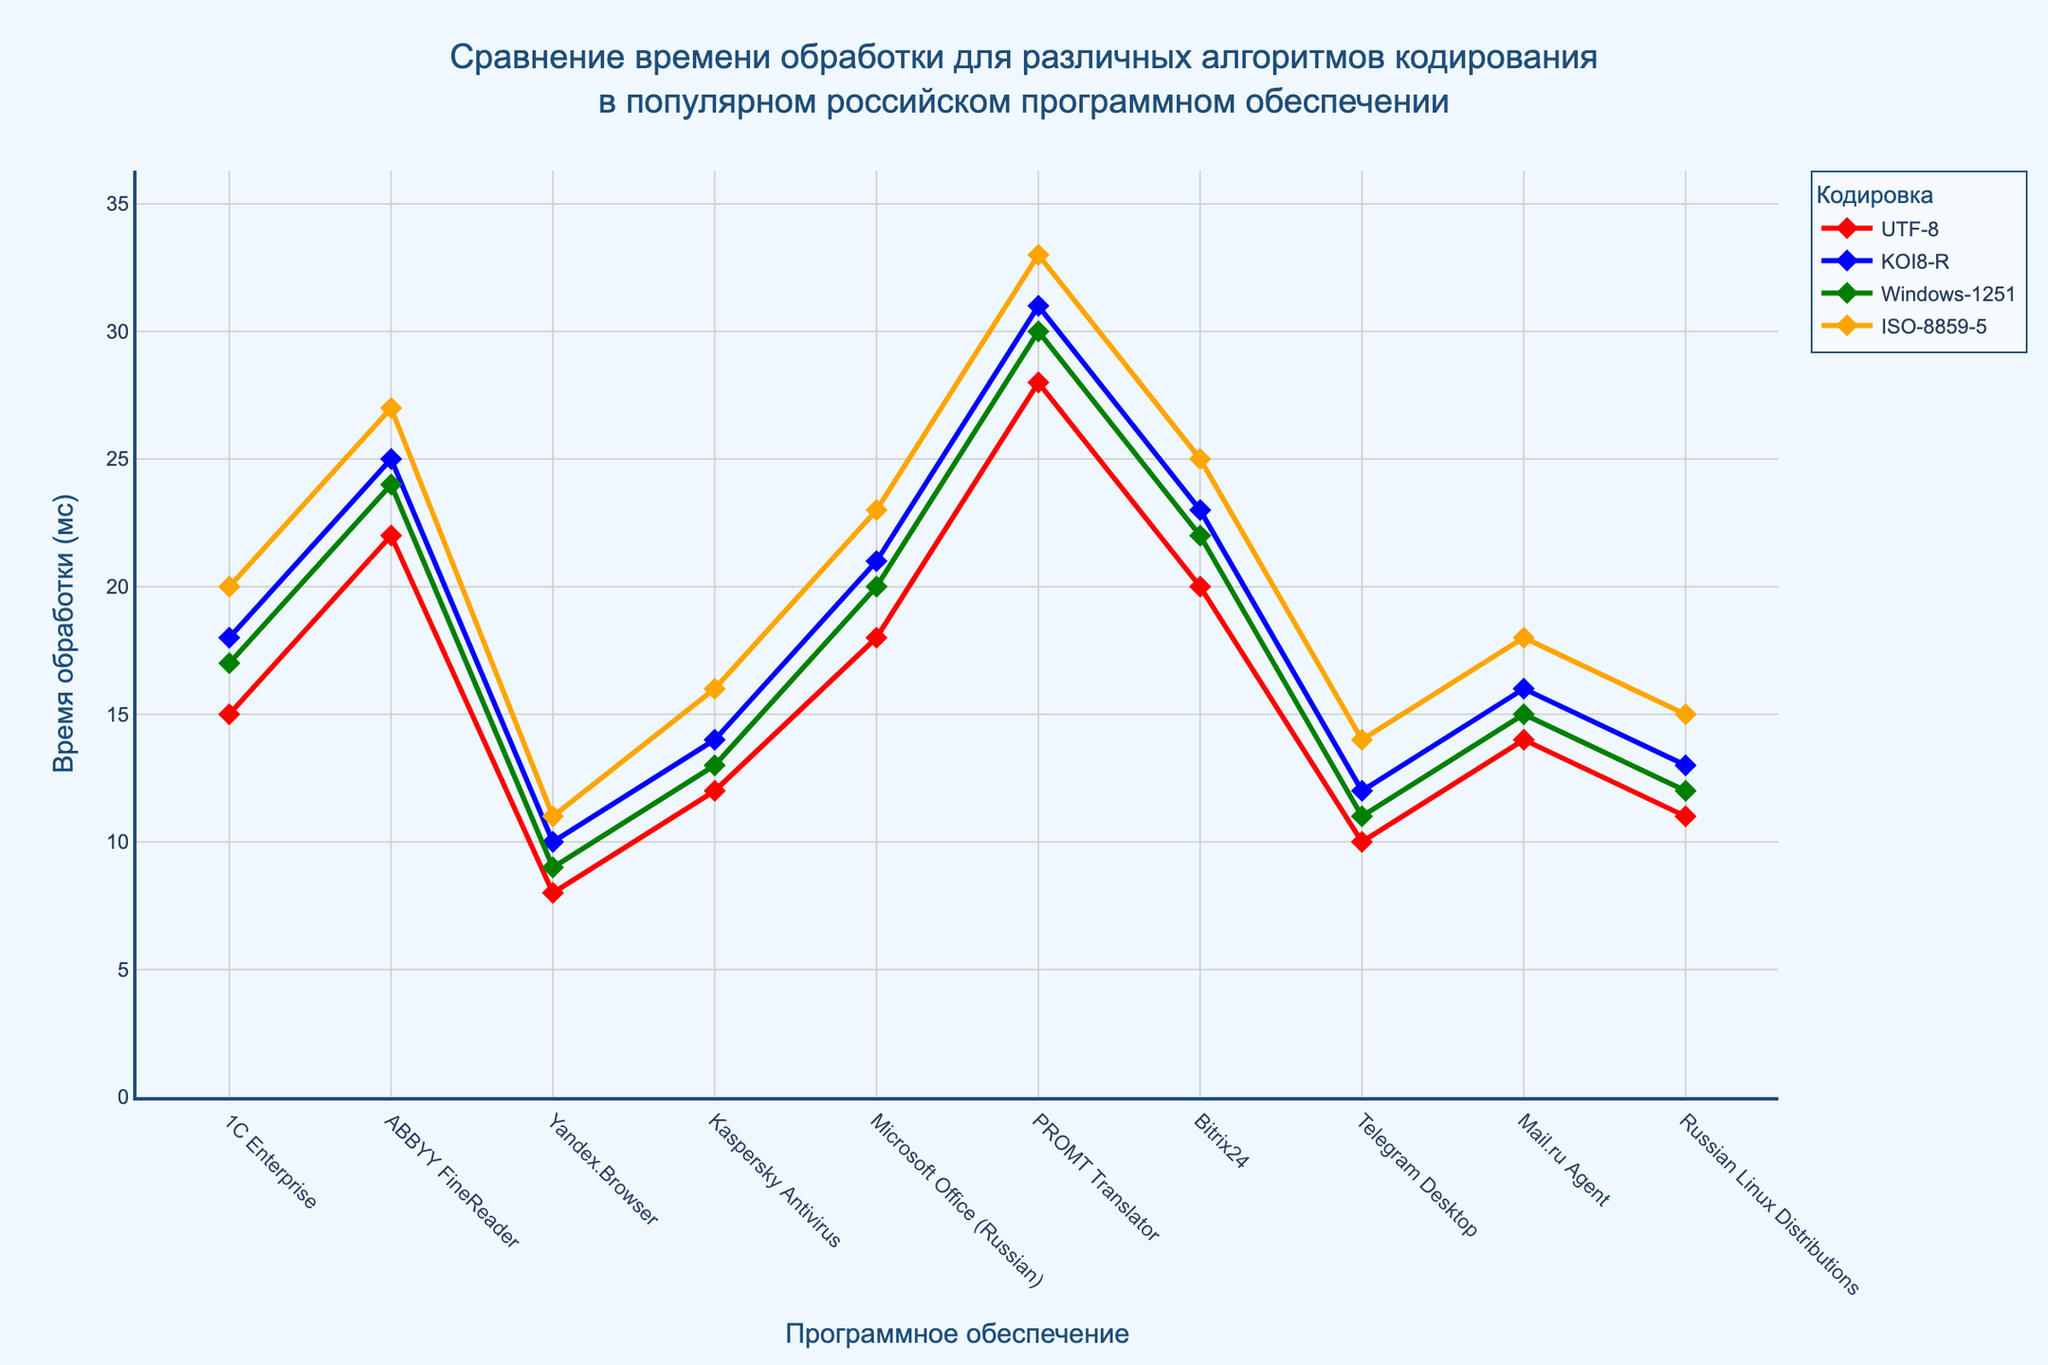Which encoding algorithm has the highest processing time for PROMT Translator? Look at the PROMT Translator row and note the processing times for each encoding. The highest value is 33 ms for ISO-8859-5.
Answer: ISO-8859-5 What is the average processing time for Yandex.Browser across all encoding algorithms? Sum the processing times for all encoding algorithms in Yandex.Browser (8 + 10 + 9 + 11) and divide by the number of encodings (4). The average is (8 + 10 + 9 + 11) / 4 = 9.5 ms.
Answer: 9.5 ms Which encoding algorithms have the same processing time for Kaspersky Antivirus? Check the row for Kaspersky Antivirus and identify which encoding algorithms have the same processing time. Windows-1251 and ISO-8859-5 both have processing times of 16 ms.
Answer: Windows-1251, ISO-8859-5 Which software shows the smallest difference in processing times between UTF-8 and KOI8-R? Calculate the difference between UTF-8 and KOI8-R for each software, then identify the smallest value. The smallest difference is 2 ms for Yandex.Browser (10 - 8).
Answer: Yandex.Browser What is the total processing time for 1C Enterprise across all encoding algorithms? Sum the processing times for 1C Enterprise over all four encoding algorithms (15 + 18 + 17 + 20). The total is 70 ms.
Answer: 70 ms Which encoding algorithm is the fastest for Mail.ru Agent? Compare the processing times of all encoding algorithms for Mail.ru Agent and identify the smallest value. The smallest processing time is 14 ms for UTF-8.
Answer: UTF-8 Compare the processing times between ABBYY FineReader and Bitrix24 for KOI8-R encoding. Which one is higher? Look at the KOI8-R column for both ABBYY FineReader and Bitrix24, and compare their values. ABBYY FineReader has a processing time of 25 ms, while Bitrix24 is 23 ms. The higher value is 25 ms for ABBYY FineReader.
Answer: ABBYY FineReader On average, which encoding algorithm performs the best across all software? Calculate the average processing time for each encoding algorithm across all software by summing the values and dividing by the number of software (10). Compare the averages to find the smallest one. The averages are UTF-8: 15.8, KOI8-R: 18.3, Windows-1251: 17.3, ISO-8859-5: 20.3. The smallest average is for UTF-8.
Answer: UTF-8 